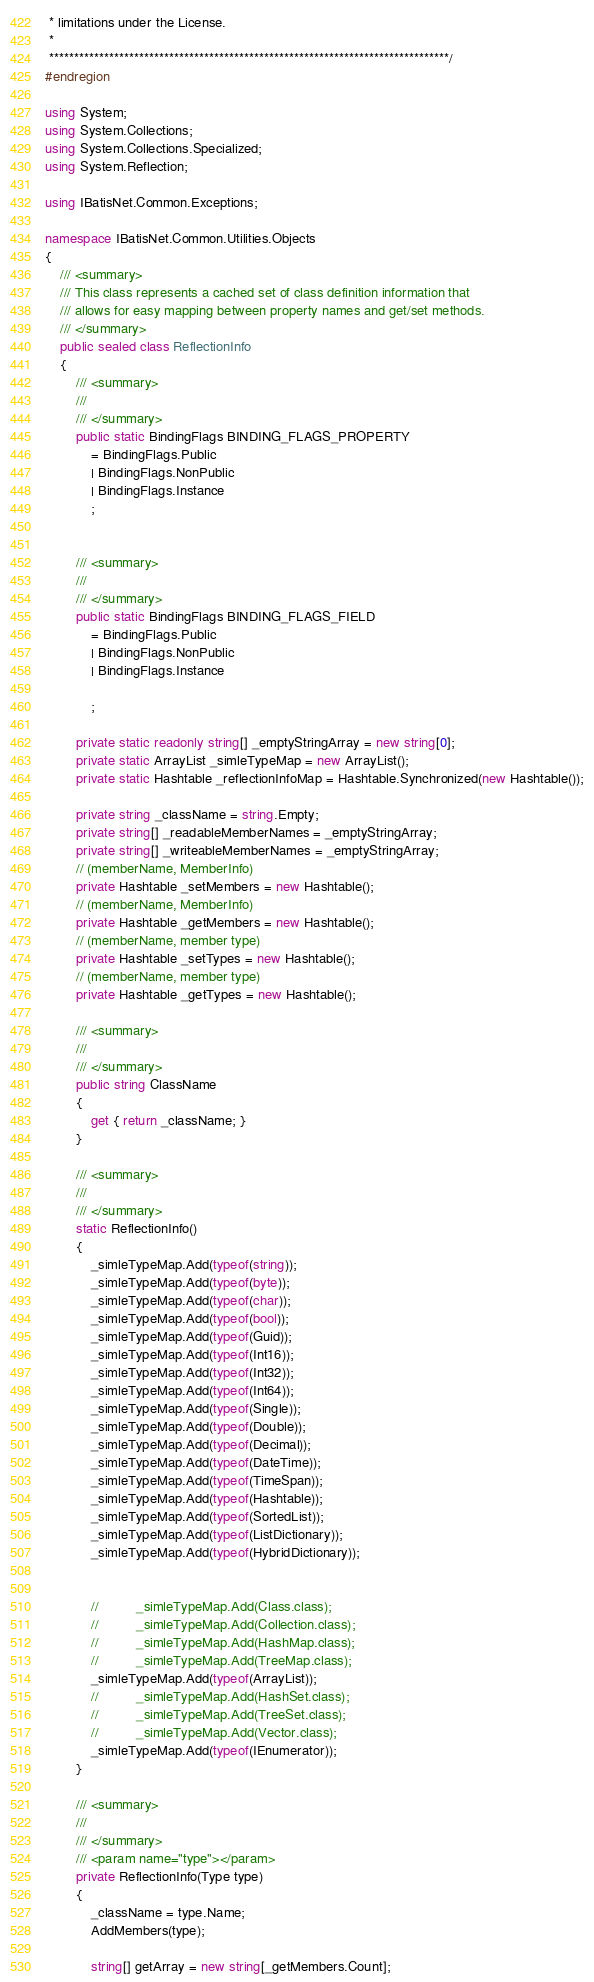Convert code to text. <code><loc_0><loc_0><loc_500><loc_500><_C#_> * limitations under the License.
 * 
 ********************************************************************************/
#endregion

using System;
using System.Collections;
using System.Collections.Specialized;
using System.Reflection;

using IBatisNet.Common.Exceptions;

namespace IBatisNet.Common.Utilities.Objects
{
	/// <summary>
	/// This class represents a cached set of class definition information that
	/// allows for easy mapping between property names and get/set methods.
	/// </summary>
    public sealed class ReflectionInfo
	{
		/// <summary>
		/// 
		/// </summary>
		public static BindingFlags BINDING_FLAGS_PROPERTY
			= BindingFlags.Public
            | BindingFlags.NonPublic
			| BindingFlags.Instance
			;


		/// <summary>
		/// 
		/// </summary>
		public static BindingFlags BINDING_FLAGS_FIELD
            = BindingFlags.Public
            | BindingFlags.NonPublic 
			| BindingFlags.Instance 

			;

		private static readonly string[] _emptyStringArray = new string[0];
		private static ArrayList _simleTypeMap = new ArrayList();
		private static Hashtable _reflectionInfoMap = Hashtable.Synchronized(new Hashtable());

		private string _className = string.Empty;
		private string[] _readableMemberNames = _emptyStringArray;
		private string[] _writeableMemberNames = _emptyStringArray;
		// (memberName, MemberInfo)
		private Hashtable _setMembers = new Hashtable();
        // (memberName, MemberInfo)
		private Hashtable _getMembers = new Hashtable();
		// (memberName, member type)
		private Hashtable _setTypes = new Hashtable();
		// (memberName, member type)
		private Hashtable _getTypes = new Hashtable();

		/// <summary>
		/// 
		/// </summary>
		public string ClassName 
		{
			get { return _className; }
		}

		/// <summary>
		/// 
		/// </summary>
		static ReflectionInfo()
		{
			_simleTypeMap.Add(typeof(string));
			_simleTypeMap.Add(typeof(byte));
			_simleTypeMap.Add(typeof(char));
			_simleTypeMap.Add(typeof(bool));
			_simleTypeMap.Add(typeof(Guid));
			_simleTypeMap.Add(typeof(Int16));
			_simleTypeMap.Add(typeof(Int32));
			_simleTypeMap.Add(typeof(Int64));
			_simleTypeMap.Add(typeof(Single));
			_simleTypeMap.Add(typeof(Double));
			_simleTypeMap.Add(typeof(Decimal));
			_simleTypeMap.Add(typeof(DateTime));
			_simleTypeMap.Add(typeof(TimeSpan));
			_simleTypeMap.Add(typeof(Hashtable));
			_simleTypeMap.Add(typeof(SortedList));
			_simleTypeMap.Add(typeof(ListDictionary));
			_simleTypeMap.Add(typeof(HybridDictionary));


			//			_simleTypeMap.Add(Class.class);
			//			_simleTypeMap.Add(Collection.class);
			//			_simleTypeMap.Add(HashMap.class);
			//			_simleTypeMap.Add(TreeMap.class);
			_simleTypeMap.Add(typeof(ArrayList));
			//			_simleTypeMap.Add(HashSet.class);
			//			_simleTypeMap.Add(TreeSet.class);
			//			_simleTypeMap.Add(Vector.class);
			_simleTypeMap.Add(typeof(IEnumerator));
		}

		/// <summary>
		/// 
		/// </summary>
		/// <param name="type"></param>
		private ReflectionInfo(Type type) 
		{
			_className = type.Name;
			AddMembers(type);

			string[] getArray = new string[_getMembers.Count];</code> 